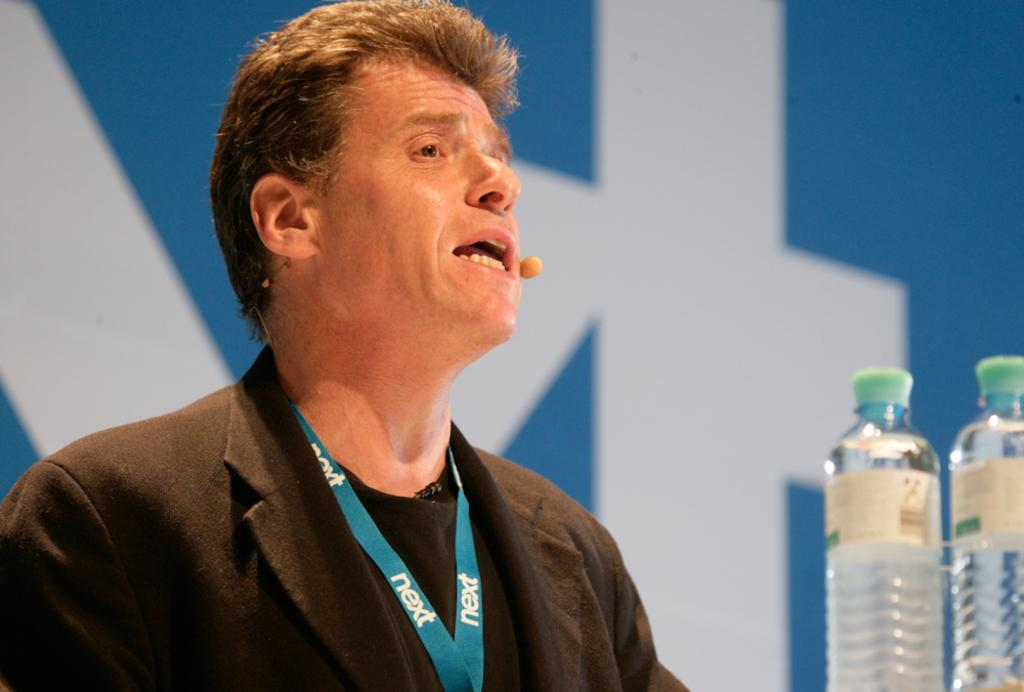Who is present in the image? There is a man in the image. What is the man wearing that is visible in the image? The man is wearing an identity card. What is the man doing in the image? The man is talking. Where are the bottles with a label located in the image? The bottles are on the right side of the image. What can be seen in the background of the image? There is a poster in the background of the image. What type of meal is being prepared in the image? There is no meal preparation visible in the image. What is the value of the bottles in the image? The value of the bottles cannot be determined from the image alone, as it depends on factors such as their contents and condition. 